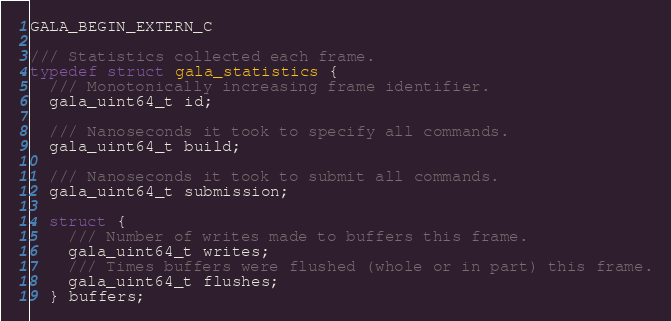<code> <loc_0><loc_0><loc_500><loc_500><_C_>
GALA_BEGIN_EXTERN_C

/// Statistics collected each frame.
typedef struct gala_statistics {
  /// Monotonically increasing frame identifier.
  gala_uint64_t id;

  /// Nanoseconds it took to specify all commands.
  gala_uint64_t build;

  /// Nanoseconds it took to submit all commands.
  gala_uint64_t submission;

  struct {
    /// Number of writes made to buffers this frame.
    gala_uint64_t writes;
    /// Times buffers were flushed (whole or in part) this frame.
    gala_uint64_t flushes;
  } buffers;</code> 